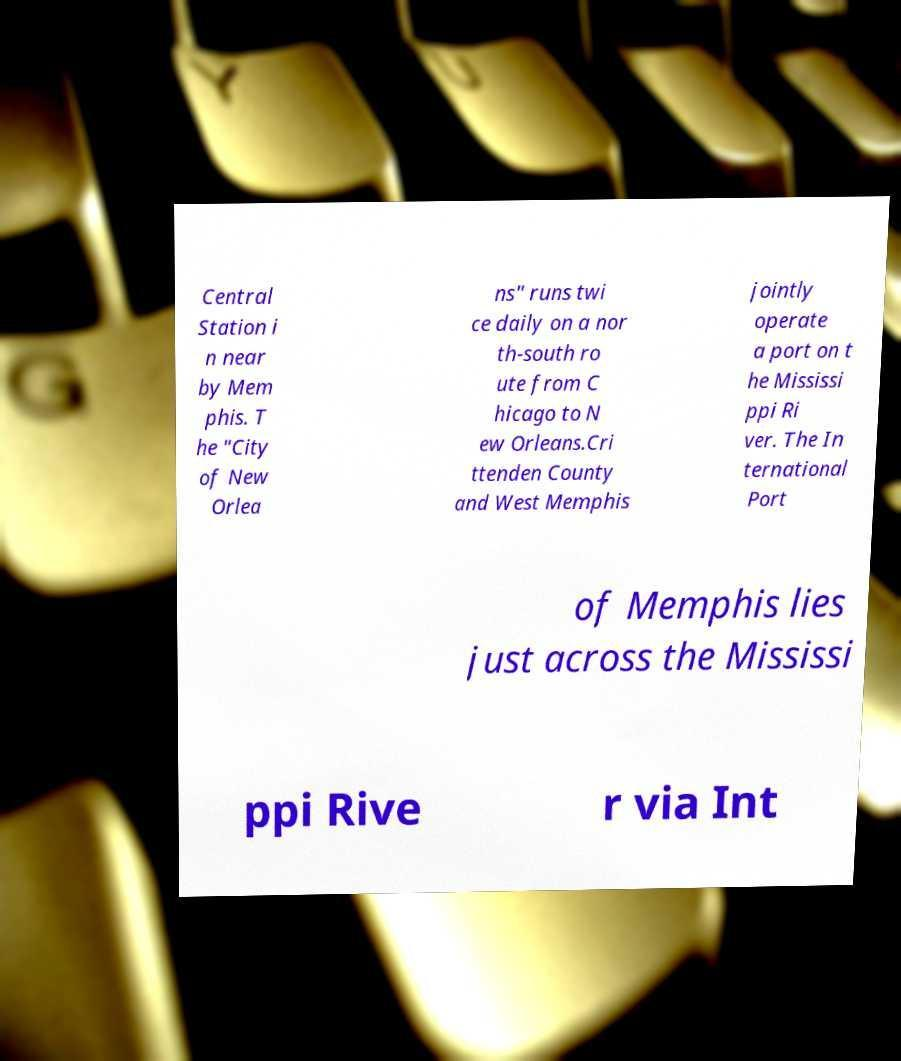Please identify and transcribe the text found in this image. Central Station i n near by Mem phis. T he "City of New Orlea ns" runs twi ce daily on a nor th-south ro ute from C hicago to N ew Orleans.Cri ttenden County and West Memphis jointly operate a port on t he Mississi ppi Ri ver. The In ternational Port of Memphis lies just across the Mississi ppi Rive r via Int 